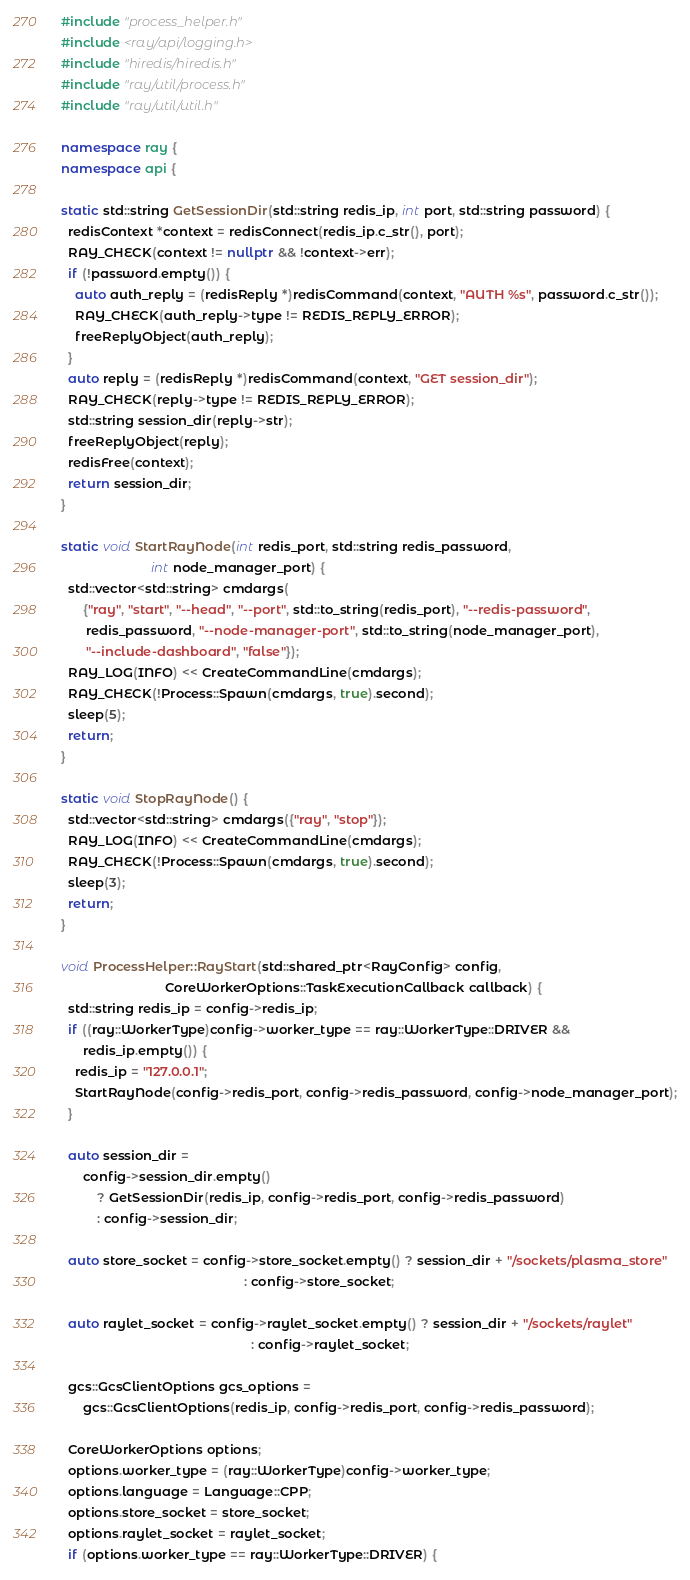Convert code to text. <code><loc_0><loc_0><loc_500><loc_500><_C++_>#include "process_helper.h"
#include <ray/api/logging.h>
#include "hiredis/hiredis.h"
#include "ray/util/process.h"
#include "ray/util/util.h"

namespace ray {
namespace api {

static std::string GetSessionDir(std::string redis_ip, int port, std::string password) {
  redisContext *context = redisConnect(redis_ip.c_str(), port);
  RAY_CHECK(context != nullptr && !context->err);
  if (!password.empty()) {
    auto auth_reply = (redisReply *)redisCommand(context, "AUTH %s", password.c_str());
    RAY_CHECK(auth_reply->type != REDIS_REPLY_ERROR);
    freeReplyObject(auth_reply);
  }
  auto reply = (redisReply *)redisCommand(context, "GET session_dir");
  RAY_CHECK(reply->type != REDIS_REPLY_ERROR);
  std::string session_dir(reply->str);
  freeReplyObject(reply);
  redisFree(context);
  return session_dir;
}

static void StartRayNode(int redis_port, std::string redis_password,
                         int node_manager_port) {
  std::vector<std::string> cmdargs(
      {"ray", "start", "--head", "--port", std::to_string(redis_port), "--redis-password",
       redis_password, "--node-manager-port", std::to_string(node_manager_port),
       "--include-dashboard", "false"});
  RAY_LOG(INFO) << CreateCommandLine(cmdargs);
  RAY_CHECK(!Process::Spawn(cmdargs, true).second);
  sleep(5);
  return;
}

static void StopRayNode() {
  std::vector<std::string> cmdargs({"ray", "stop"});
  RAY_LOG(INFO) << CreateCommandLine(cmdargs);
  RAY_CHECK(!Process::Spawn(cmdargs, true).second);
  sleep(3);
  return;
}

void ProcessHelper::RayStart(std::shared_ptr<RayConfig> config,
                             CoreWorkerOptions::TaskExecutionCallback callback) {
  std::string redis_ip = config->redis_ip;
  if ((ray::WorkerType)config->worker_type == ray::WorkerType::DRIVER &&
      redis_ip.empty()) {
    redis_ip = "127.0.0.1";
    StartRayNode(config->redis_port, config->redis_password, config->node_manager_port);
  }

  auto session_dir =
      config->session_dir.empty()
          ? GetSessionDir(redis_ip, config->redis_port, config->redis_password)
          : config->session_dir;

  auto store_socket = config->store_socket.empty() ? session_dir + "/sockets/plasma_store"
                                                   : config->store_socket;

  auto raylet_socket = config->raylet_socket.empty() ? session_dir + "/sockets/raylet"
                                                     : config->raylet_socket;

  gcs::GcsClientOptions gcs_options =
      gcs::GcsClientOptions(redis_ip, config->redis_port, config->redis_password);

  CoreWorkerOptions options;
  options.worker_type = (ray::WorkerType)config->worker_type;
  options.language = Language::CPP;
  options.store_socket = store_socket;
  options.raylet_socket = raylet_socket;
  if (options.worker_type == ray::WorkerType::DRIVER) {</code> 